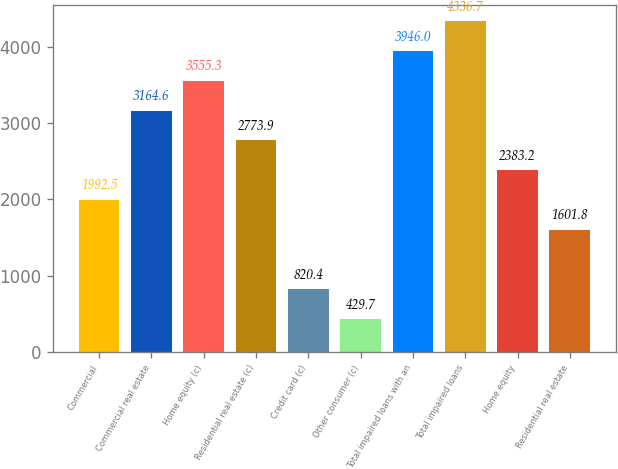<chart> <loc_0><loc_0><loc_500><loc_500><bar_chart><fcel>Commercial<fcel>Commercial real estate<fcel>Home equity (c)<fcel>Residential real estate (c)<fcel>Credit card (c)<fcel>Other consumer (c)<fcel>Total impaired loans with an<fcel>Total impaired loans<fcel>Home equity<fcel>Residential real estate<nl><fcel>1992.5<fcel>3164.6<fcel>3555.3<fcel>2773.9<fcel>820.4<fcel>429.7<fcel>3946<fcel>4336.7<fcel>2383.2<fcel>1601.8<nl></chart> 